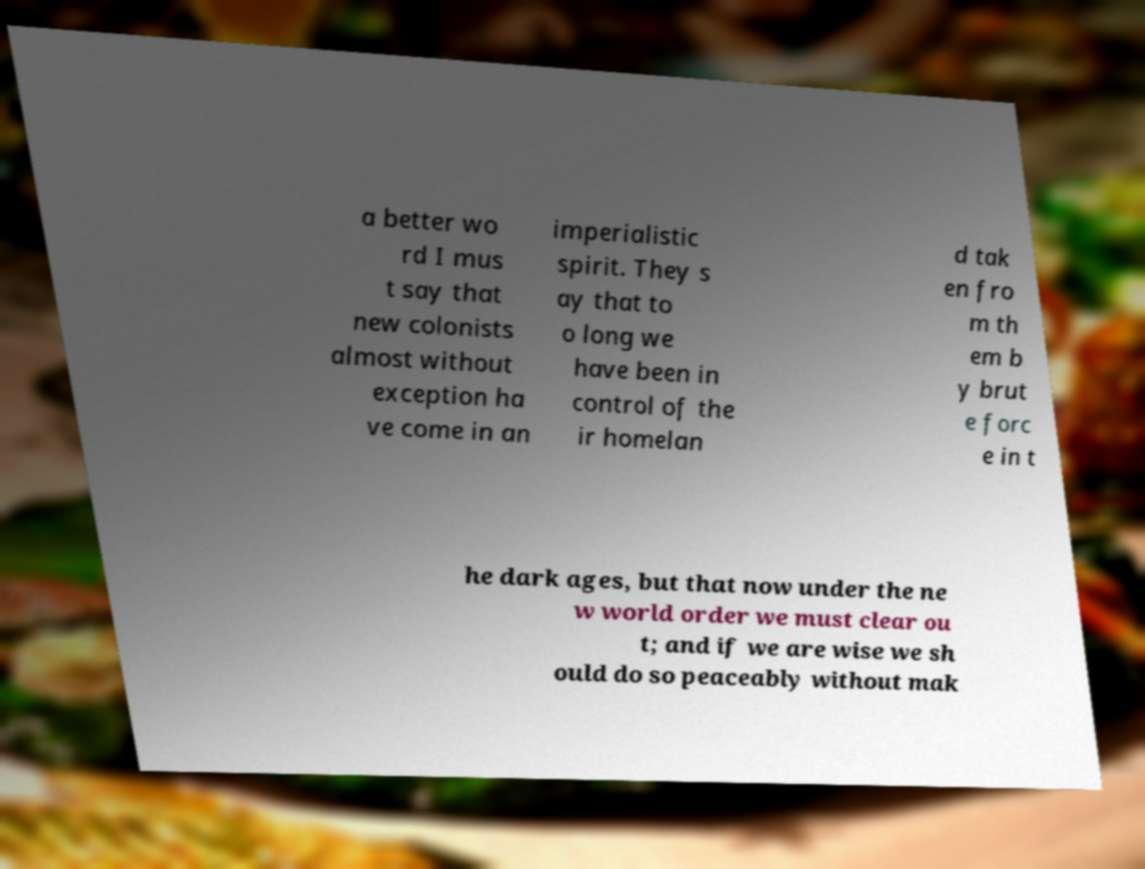There's text embedded in this image that I need extracted. Can you transcribe it verbatim? a better wo rd I mus t say that new colonists almost without exception ha ve come in an imperialistic spirit. They s ay that to o long we have been in control of the ir homelan d tak en fro m th em b y brut e forc e in t he dark ages, but that now under the ne w world order we must clear ou t; and if we are wise we sh ould do so peaceably without mak 